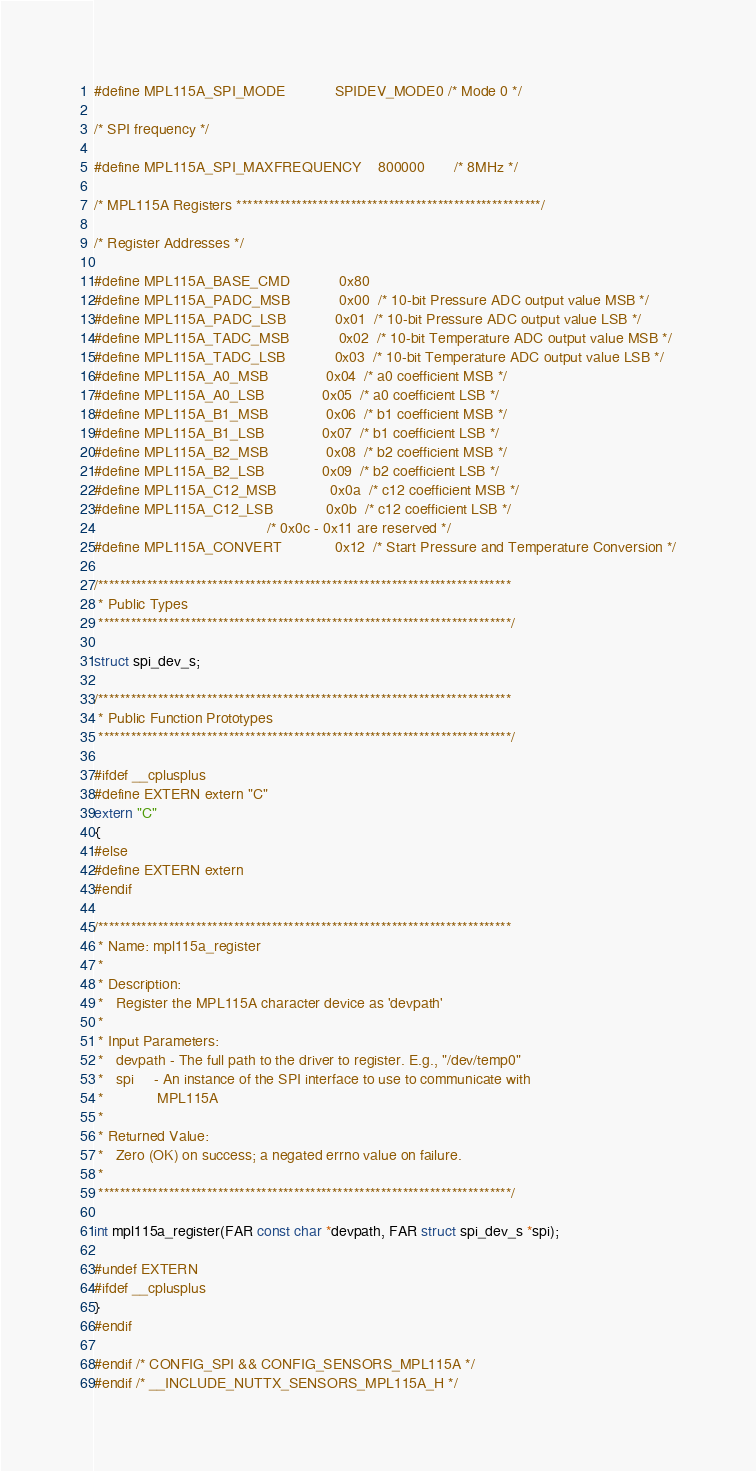<code> <loc_0><loc_0><loc_500><loc_500><_C_>
#define MPL115A_SPI_MODE            SPIDEV_MODE0 /* Mode 0 */

/* SPI frequency */

#define MPL115A_SPI_MAXFREQUENCY    800000       /* 8MHz */

/* MPL115A Registers ********************************************************/

/* Register Addresses */

#define MPL115A_BASE_CMD            0x80
#define MPL115A_PADC_MSB            0x00  /* 10-bit Pressure ADC output value MSB */
#define MPL115A_PADC_LSB            0x01  /* 10-bit Pressure ADC output value LSB */
#define MPL115A_TADC_MSB            0x02  /* 10-bit Temperature ADC output value MSB */
#define MPL115A_TADC_LSB            0x03  /* 10-bit Temperature ADC output value LSB */
#define MPL115A_A0_MSB              0x04  /* a0 coefficient MSB */
#define MPL115A_A0_LSB              0x05  /* a0 coefficient LSB */
#define MPL115A_B1_MSB              0x06  /* b1 coefficient MSB */
#define MPL115A_B1_LSB              0x07  /* b1 coefficient LSB */
#define MPL115A_B2_MSB              0x08  /* b2 coefficient MSB */
#define MPL115A_B2_LSB              0x09  /* b2 coefficient LSB */
#define MPL115A_C12_MSB             0x0a  /* c12 coefficient MSB */
#define MPL115A_C12_LSB             0x0b  /* c12 coefficient LSB */
                                          /* 0x0c - 0x11 are reserved */
#define MPL115A_CONVERT             0x12  /* Start Pressure and Temperature Conversion */

/****************************************************************************
 * Public Types
 ****************************************************************************/

struct spi_dev_s;

/****************************************************************************
 * Public Function Prototypes
 ****************************************************************************/

#ifdef __cplusplus
#define EXTERN extern "C"
extern "C"
{
#else
#define EXTERN extern
#endif

/****************************************************************************
 * Name: mpl115a_register
 *
 * Description:
 *   Register the MPL115A character device as 'devpath'
 *
 * Input Parameters:
 *   devpath - The full path to the driver to register. E.g., "/dev/temp0"
 *   spi     - An instance of the SPI interface to use to communicate with
 *             MPL115A
 *
 * Returned Value:
 *   Zero (OK) on success; a negated errno value on failure.
 *
 ****************************************************************************/

int mpl115a_register(FAR const char *devpath, FAR struct spi_dev_s *spi);

#undef EXTERN
#ifdef __cplusplus
}
#endif

#endif /* CONFIG_SPI && CONFIG_SENSORS_MPL115A */
#endif /* __INCLUDE_NUTTX_SENSORS_MPL115A_H */
</code> 